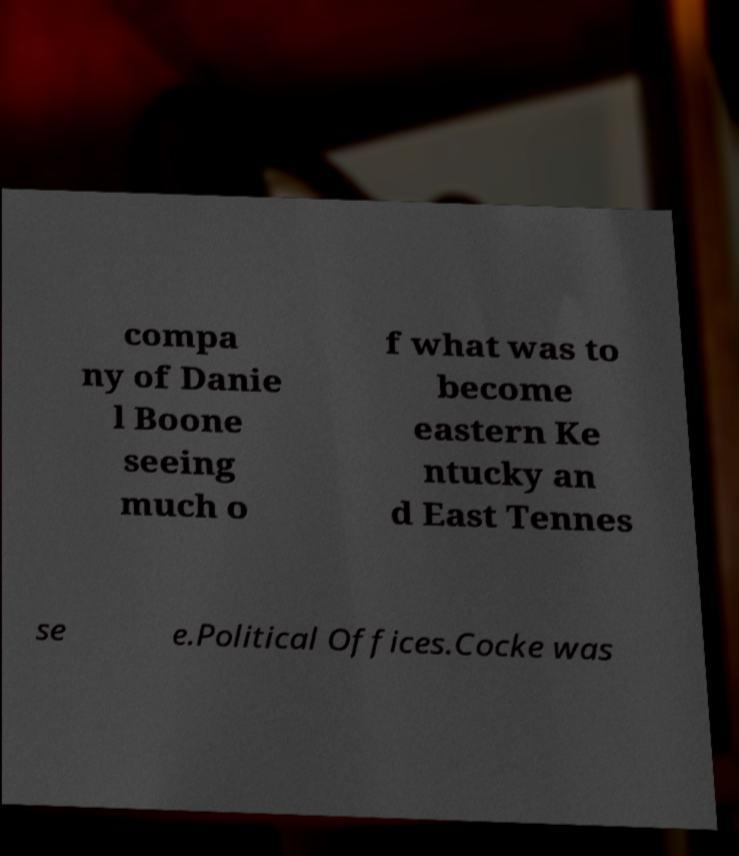Can you accurately transcribe the text from the provided image for me? compa ny of Danie l Boone seeing much o f what was to become eastern Ke ntucky an d East Tennes se e.Political Offices.Cocke was 